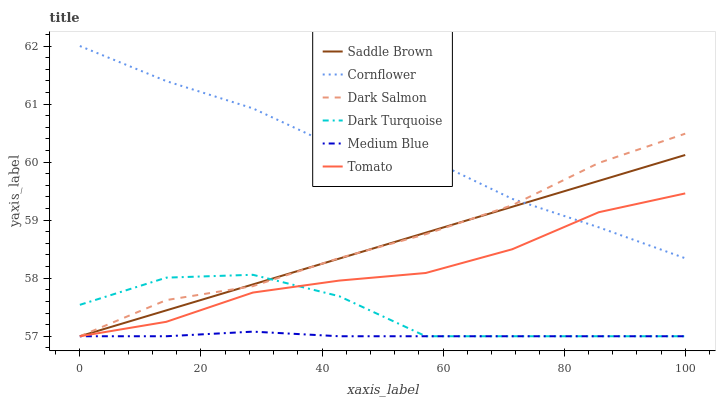Does Medium Blue have the minimum area under the curve?
Answer yes or no. Yes. Does Cornflower have the maximum area under the curve?
Answer yes or no. Yes. Does Dark Turquoise have the minimum area under the curve?
Answer yes or no. No. Does Dark Turquoise have the maximum area under the curve?
Answer yes or no. No. Is Saddle Brown the smoothest?
Answer yes or no. Yes. Is Dark Turquoise the roughest?
Answer yes or no. Yes. Is Cornflower the smoothest?
Answer yes or no. No. Is Cornflower the roughest?
Answer yes or no. No. Does Tomato have the lowest value?
Answer yes or no. Yes. Does Cornflower have the lowest value?
Answer yes or no. No. Does Cornflower have the highest value?
Answer yes or no. Yes. Does Dark Turquoise have the highest value?
Answer yes or no. No. Is Medium Blue less than Cornflower?
Answer yes or no. Yes. Is Cornflower greater than Dark Turquoise?
Answer yes or no. Yes. Does Dark Salmon intersect Medium Blue?
Answer yes or no. Yes. Is Dark Salmon less than Medium Blue?
Answer yes or no. No. Is Dark Salmon greater than Medium Blue?
Answer yes or no. No. Does Medium Blue intersect Cornflower?
Answer yes or no. No. 